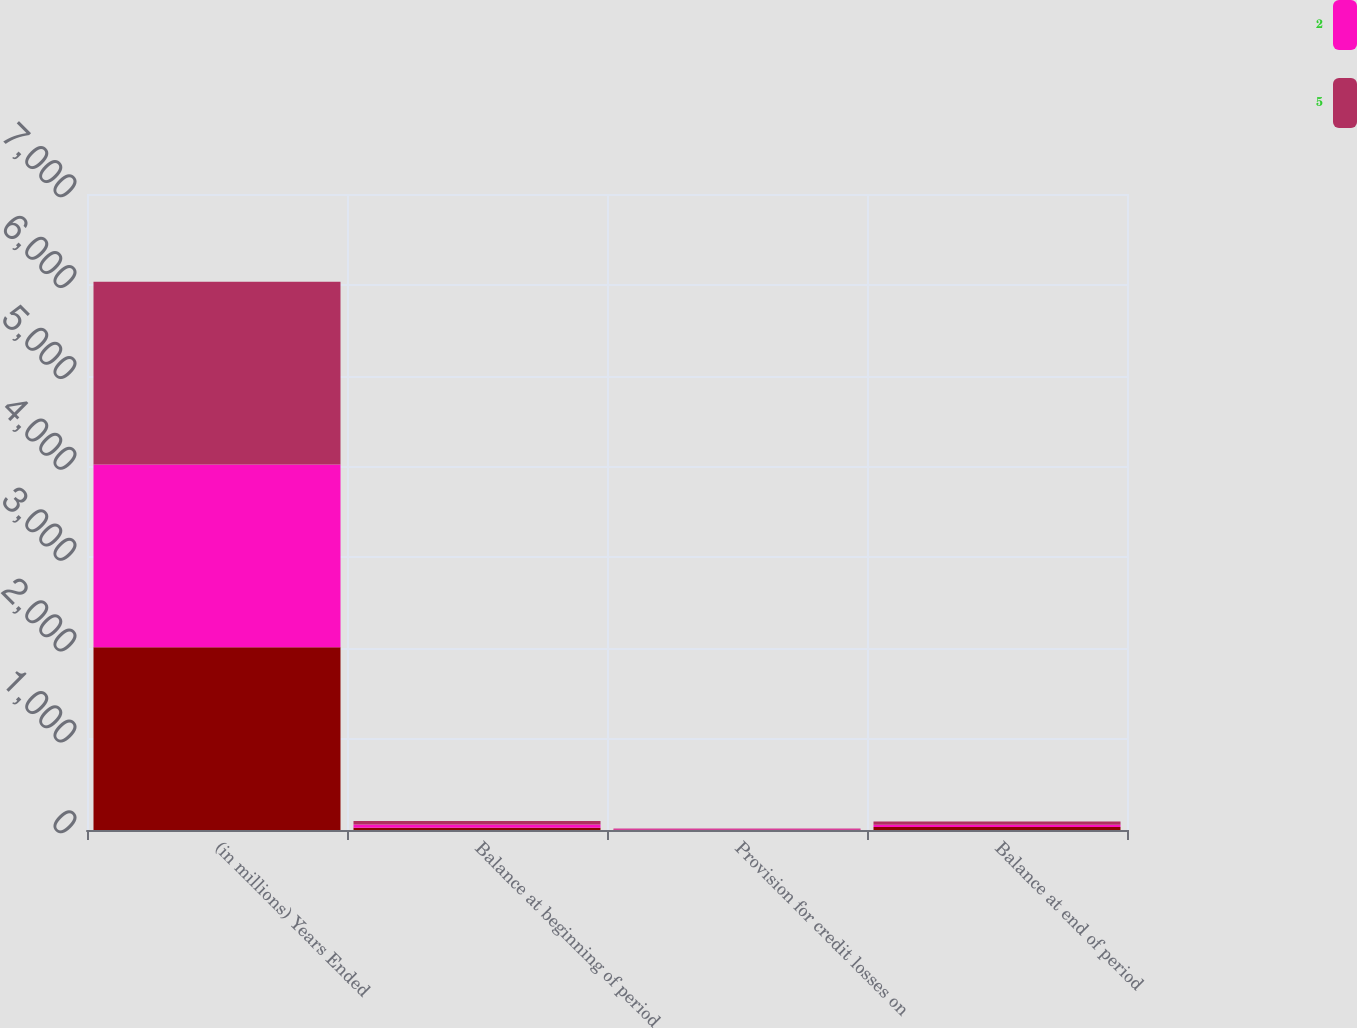Convert chart to OTSL. <chart><loc_0><loc_0><loc_500><loc_500><stacked_bar_chart><ecel><fcel>(in millions) Years Ended<fcel>Balance at beginning of period<fcel>Provision for credit losses on<fcel>Balance at end of period<nl><fcel>nan<fcel>2012<fcel>26<fcel>6<fcel>32<nl><fcel>2<fcel>2011<fcel>35<fcel>9<fcel>26<nl><fcel>5<fcel>2010<fcel>37<fcel>2<fcel>35<nl></chart> 